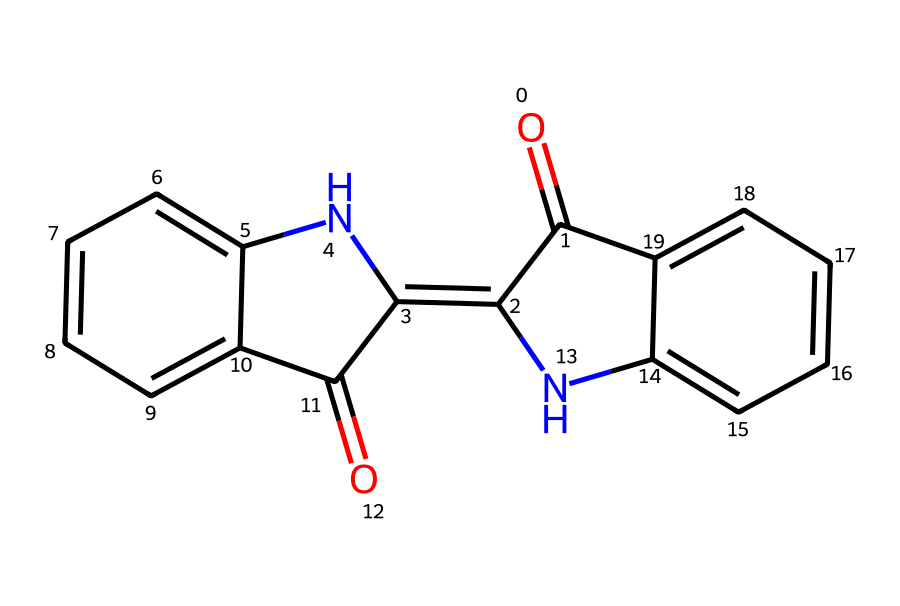What is the number of carbon atoms in this molecule? By analyzing the structure deduced from the SMILES representation, we can count the carbon (C) atoms present. The molecule shows multiple interconnected rings and substituents; from a detailed count, we find that there are a total of 15 carbon atoms.
Answer: 15 How many nitrogen atoms are present in this structure? In the provided SMILES representation, there are two distinct nitrogen (N) atoms. A quick inspection reveals two instances of 'N', confirming the total count of nitrogen atoms as 2.
Answer: 2 What is the primary functional group in this chemical? Given the structure, the defining characteristic is the presence of carbonyl groups (C=O) and nitrogen atoms. The combination indicates that this molecule features amides and possibly imines, categorized as nitrogenous compounds.
Answer: amide Does this chemical structure contain any aromatic rings? An examination of the structure shows several connected carbon rings with alternating double bonds, which are characteristic of aromatic rings. The presence of these features confirms that the structure does indeed include aromatic rings.
Answer: yes What type of dye is commonly derived from the compounds associated with this structure? Given the nitrogen and aromatic characteristics of the molecule, it is commonly associated with indigo dyes, historically utilized in Mayan textiles for deep blue coloration.
Answer: indigo How many double bonds are present in the molecule? By inspecting the structure based on the SMILES representation, we can observe a total of 6 double bonds connecting various atoms. This includes double bonds in the carbon rings and functional groups.
Answer: 6 What is the molecular weight of this compound? To calculate the molecular weight, we sum the atomic weights of all the constituent atoms: carbon, hydrogen, nitrogen, and oxygen. After performing the calculation based on the structure derived from the SMILES code, the molecular weight comes out to be approximately 276.3 g/mol.
Answer: 276.3 